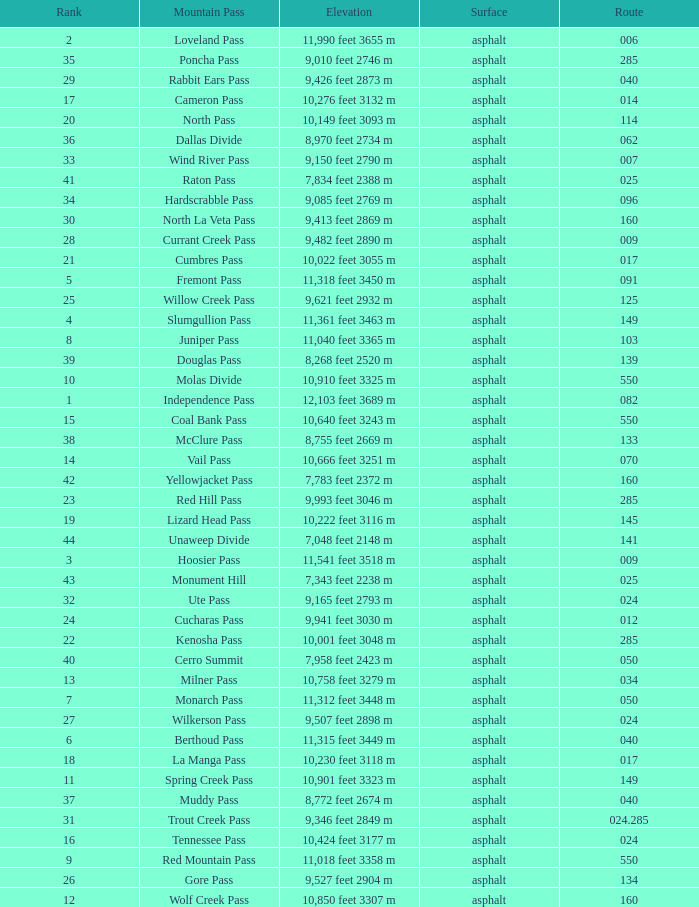What is the Surface of the Route less than 7? Asphalt. 